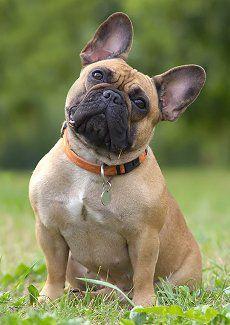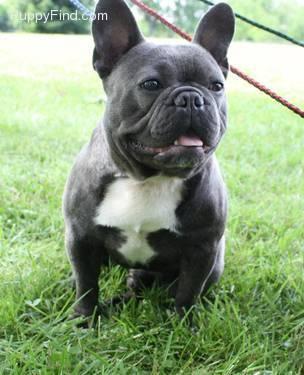The first image is the image on the left, the second image is the image on the right. Considering the images on both sides, is "There is at least one mostly black dog standing on all four legs in the image on the left." valid? Answer yes or no. No. 